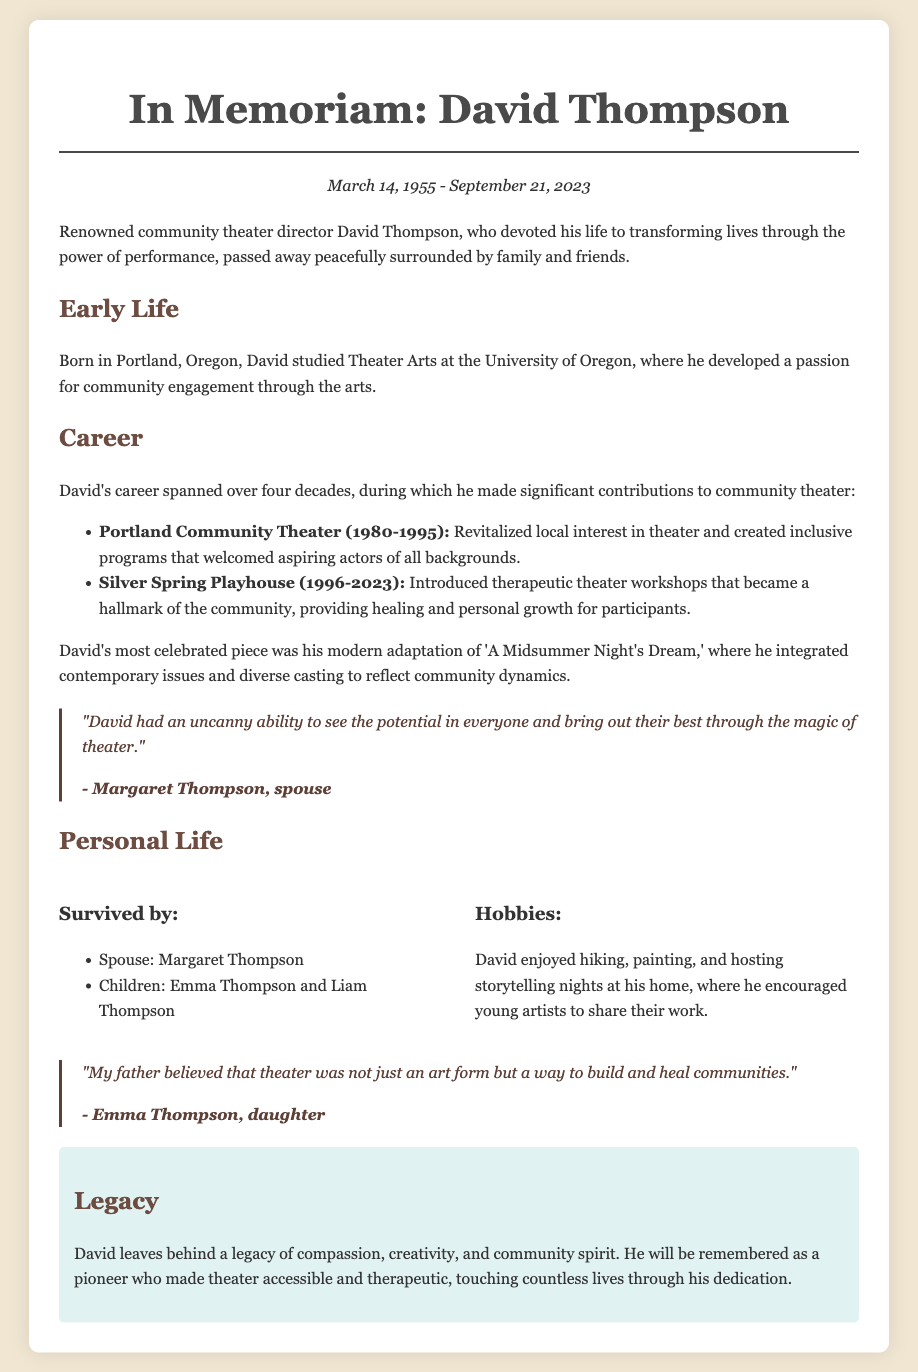What is the name of the theater director? The theater director mentioned in the document is David Thompson.
Answer: David Thompson What year did David start his career at Portland Community Theater? The document states that David worked at Portland Community Theater from 1980 to 1995, indicating he started in 1980.
Answer: 1980 How many children did David have? The document lists two children, Emma Thompson and Liam Thompson.
Answer: Two What is the most celebrated piece directed by David? The most celebrated piece directed by David was a modern adaptation of 'A Midsummer Night's Dream.'
Answer: 'A Midsummer Night's Dream' What was introduced during David's tenure at Silver Spring Playhouse? The document mentions that therapeutic theater workshops were introduced during David's time at Silver Spring Playhouse.
Answer: Therapeutic theater workshops Who described David's ability to see potential in everyone? The quote attributed to Margaret Thompson highlights David's ability to see potential in others.
Answer: Margaret Thompson What did David believe theater was a way to build and heal? According to Emma Thompson, David believed that theater was a way to build and heal communities.
Answer: Communities What date did David pass away? The document states that David passed away on September 21, 2023.
Answer: September 21, 2023 